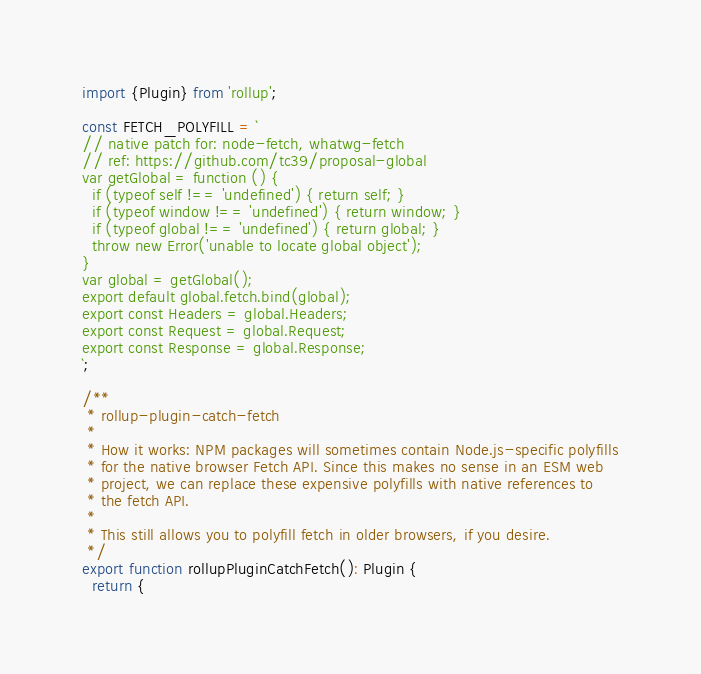Convert code to text. <code><loc_0><loc_0><loc_500><loc_500><_TypeScript_>import {Plugin} from 'rollup';

const FETCH_POLYFILL = `
// native patch for: node-fetch, whatwg-fetch
// ref: https://github.com/tc39/proposal-global
var getGlobal = function () {
  if (typeof self !== 'undefined') { return self; }
  if (typeof window !== 'undefined') { return window; }
  if (typeof global !== 'undefined') { return global; }
  throw new Error('unable to locate global object');
}
var global = getGlobal();
export default global.fetch.bind(global);
export const Headers = global.Headers;
export const Request = global.Request;
export const Response = global.Response;
`;

/**
 * rollup-plugin-catch-fetch
 *
 * How it works: NPM packages will sometimes contain Node.js-specific polyfills
 * for the native browser Fetch API. Since this makes no sense in an ESM web
 * project, we can replace these expensive polyfills with native references to
 * the fetch API.
 *
 * This still allows you to polyfill fetch in older browsers, if you desire.
 */
export function rollupPluginCatchFetch(): Plugin {
  return {</code> 